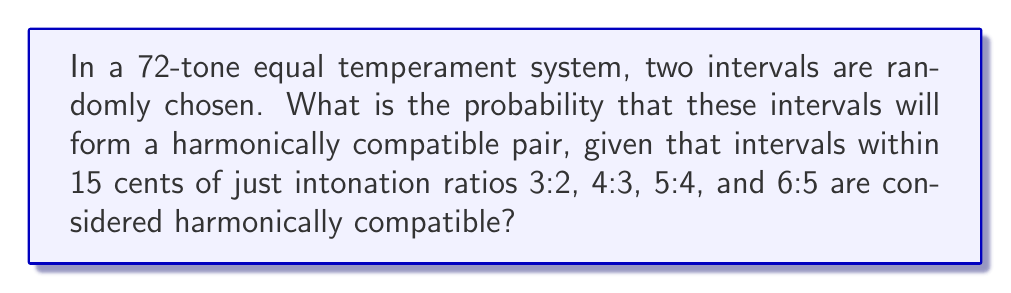Provide a solution to this math problem. Let's approach this step-by-step:

1) In a 72-tone equal temperament system, each semitone is divided into 6 equal parts (72/12 = 6). This means each step is 16.67 cents (100 cents / 6).

2) We need to determine how many intervals in this system are within 15 cents of our given just intonation ratios:

   - 3:2 (perfect fifth): 701.96 cents
   - 4:3 (perfect fourth): 498.04 cents
   - 5:4 (major third): 386.31 cents
   - 6:5 (minor third): 315.64 cents

3) Let's count the compatible intervals for each ratio:
   
   - 3:2: 42nd step (700 cents) is within 15 cents
   - 4:3: 30th step (500 cents) is within 15 cents
   - 5:4: 23rd step (383.33 cents) is within 15 cents
   - 6:5: 19th step (316.67 cents) is within 15 cents

4) Total compatible intervals: 4

5) In a 72-tone system, there are 71 possible intervals (excluding unison).

6) The probability of choosing a compatible interval is:

   $$P(\text{compatible}) = \frac{4}{71}$$

7) For two independently chosen intervals to both be compatible:

   $$P(\text{both compatible}) = P(\text{compatible}) \times P(\text{compatible}) = \frac{4}{71} \times \frac{4}{71} = \frac{16}{5041}$$
Answer: $\frac{16}{5041} \approx 0.00317$ or about $0.317\%$ 